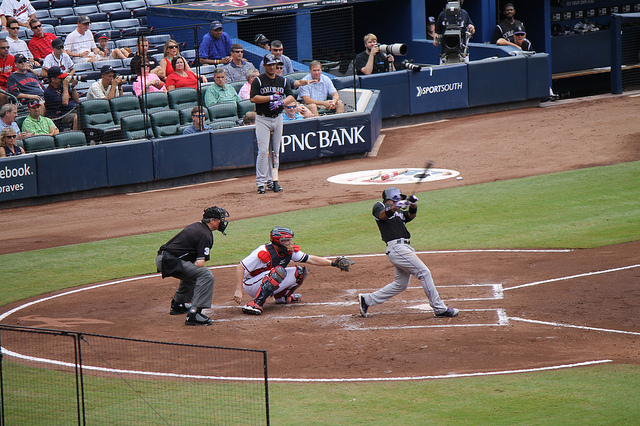Is there anything in this image that speaks to the wider culture or significance of the sport? This image is steeped in the cultural significance of baseball, often termed America's pastime. The stadium is a gathering place for fans from all walks of life, showcasing the sport's ability to bring people together. The anticipation of the crowd as they watch the pitch, exemplified by their focused attention, reflects the tension and excitement inherent in key moments of the game. Moreover, the attire of the players, including team uniforms with caps and cleats, is emblematic of the sport's long-standing traditions. Baseball has played a role in major historical narratives, including racial integration with players like Jackie Robinson, and reflects broader societal changes through its evolution over decades. 